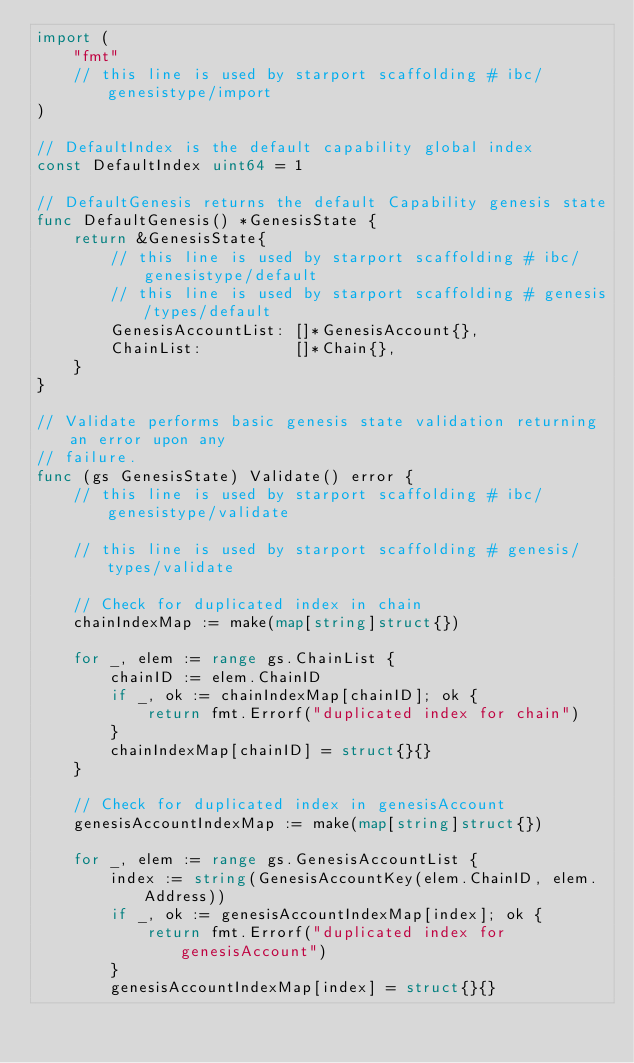<code> <loc_0><loc_0><loc_500><loc_500><_Go_>import (
	"fmt"
	// this line is used by starport scaffolding # ibc/genesistype/import
)

// DefaultIndex is the default capability global index
const DefaultIndex uint64 = 1

// DefaultGenesis returns the default Capability genesis state
func DefaultGenesis() *GenesisState {
	return &GenesisState{
		// this line is used by starport scaffolding # ibc/genesistype/default
		// this line is used by starport scaffolding # genesis/types/default
		GenesisAccountList: []*GenesisAccount{},
		ChainList:          []*Chain{},
	}
}

// Validate performs basic genesis state validation returning an error upon any
// failure.
func (gs GenesisState) Validate() error {
	// this line is used by starport scaffolding # ibc/genesistype/validate

	// this line is used by starport scaffolding # genesis/types/validate

	// Check for duplicated index in chain
	chainIndexMap := make(map[string]struct{})

	for _, elem := range gs.ChainList {
		chainID := elem.ChainID
		if _, ok := chainIndexMap[chainID]; ok {
			return fmt.Errorf("duplicated index for chain")
		}
		chainIndexMap[chainID] = struct{}{}
	}

	// Check for duplicated index in genesisAccount
	genesisAccountIndexMap := make(map[string]struct{})

	for _, elem := range gs.GenesisAccountList {
		index := string(GenesisAccountKey(elem.ChainID, elem.Address))
		if _, ok := genesisAccountIndexMap[index]; ok {
			return fmt.Errorf("duplicated index for genesisAccount")
		}
		genesisAccountIndexMap[index] = struct{}{}
</code> 